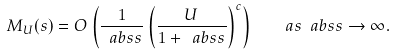Convert formula to latex. <formula><loc_0><loc_0><loc_500><loc_500>M _ { U } ( s ) = O \left ( \frac { 1 } { \ a b s { s } } \left ( \frac { U } { 1 + \ a b s { s } } \right ) ^ { c } \right ) \quad a s \ a b s { s } \to \infty .</formula> 